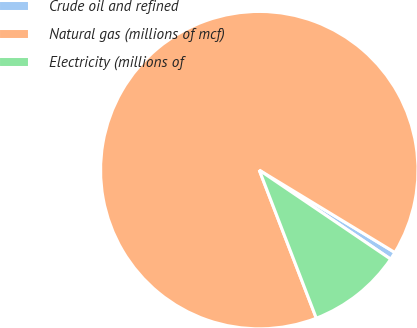Convert chart to OTSL. <chart><loc_0><loc_0><loc_500><loc_500><pie_chart><fcel>Crude oil and refined<fcel>Natural gas (millions of mcf)<fcel>Electricity (millions of<nl><fcel>0.79%<fcel>89.54%<fcel>9.67%<nl></chart> 